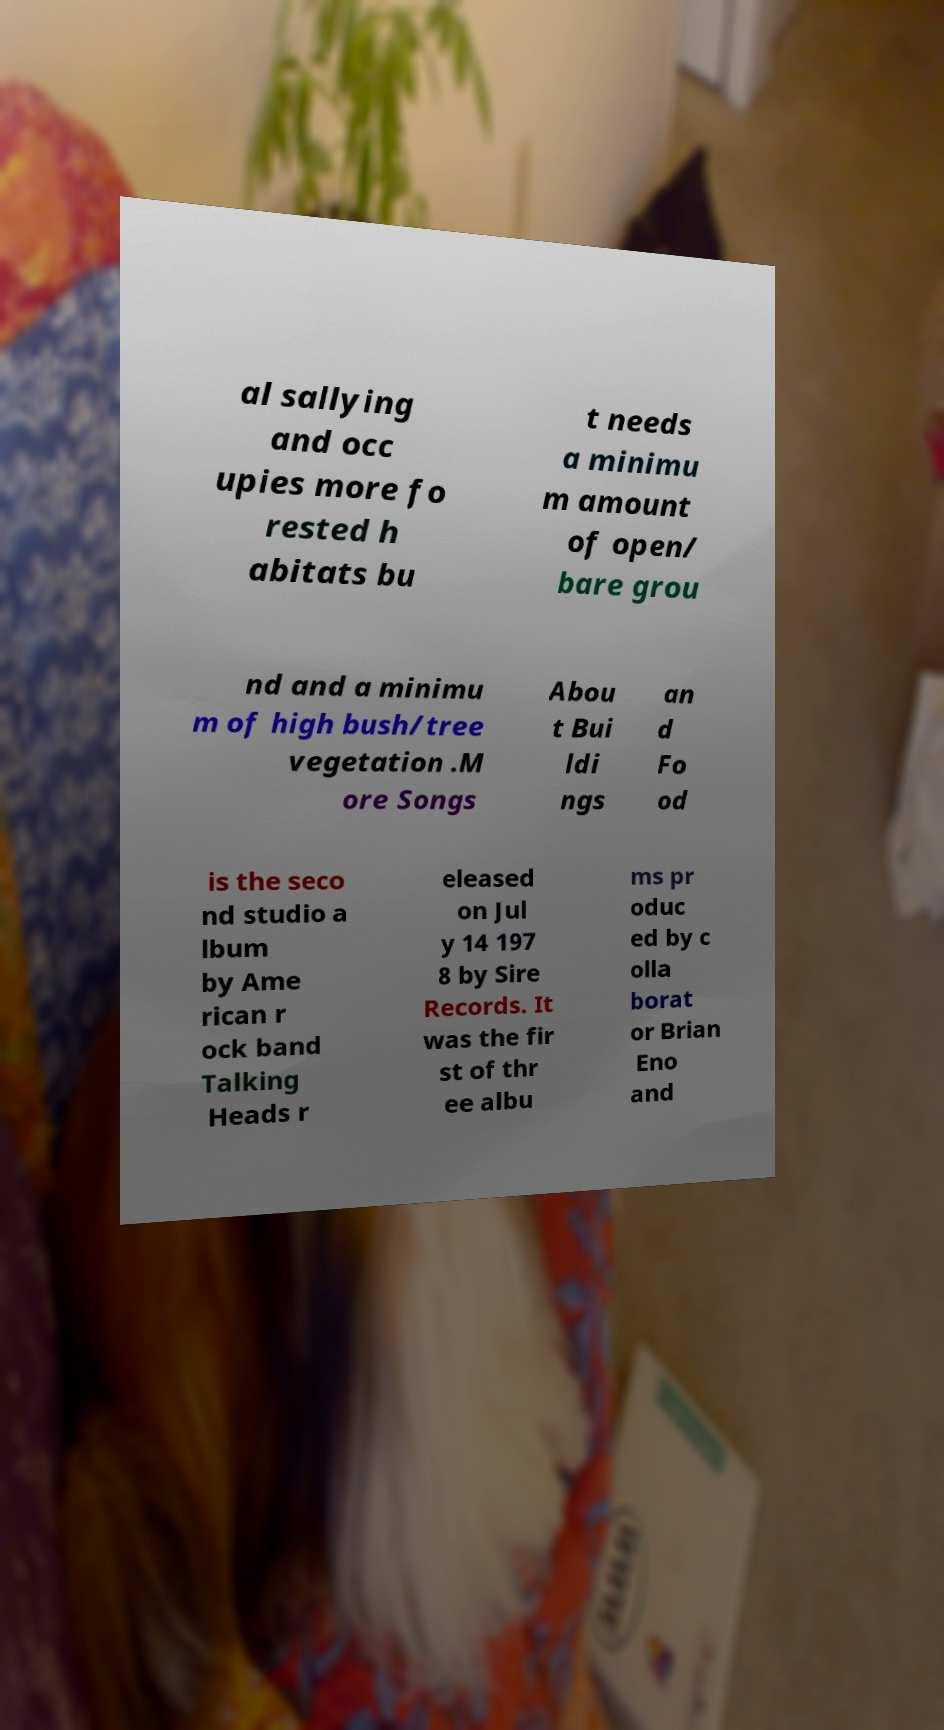Can you accurately transcribe the text from the provided image for me? al sallying and occ upies more fo rested h abitats bu t needs a minimu m amount of open/ bare grou nd and a minimu m of high bush/tree vegetation .M ore Songs Abou t Bui ldi ngs an d Fo od is the seco nd studio a lbum by Ame rican r ock band Talking Heads r eleased on Jul y 14 197 8 by Sire Records. It was the fir st of thr ee albu ms pr oduc ed by c olla borat or Brian Eno and 